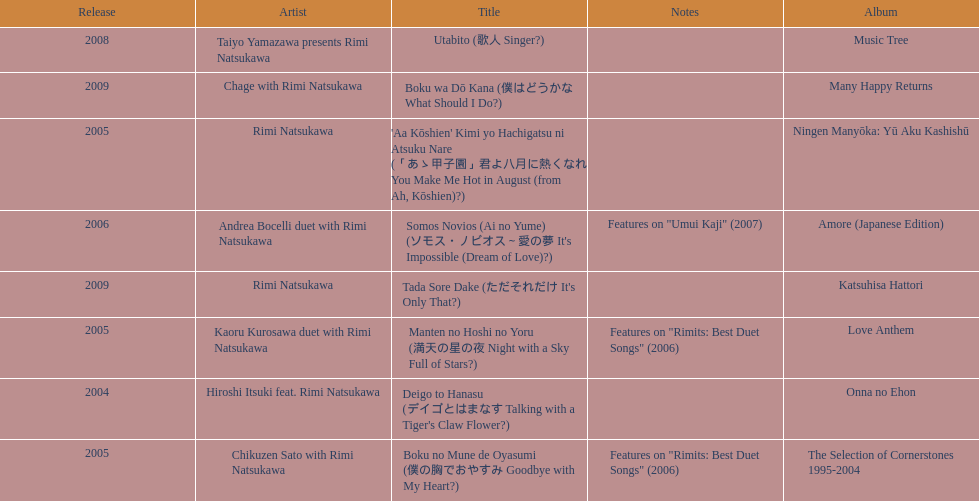What song was this artist on after utabito? Boku wa Dō Kana. 